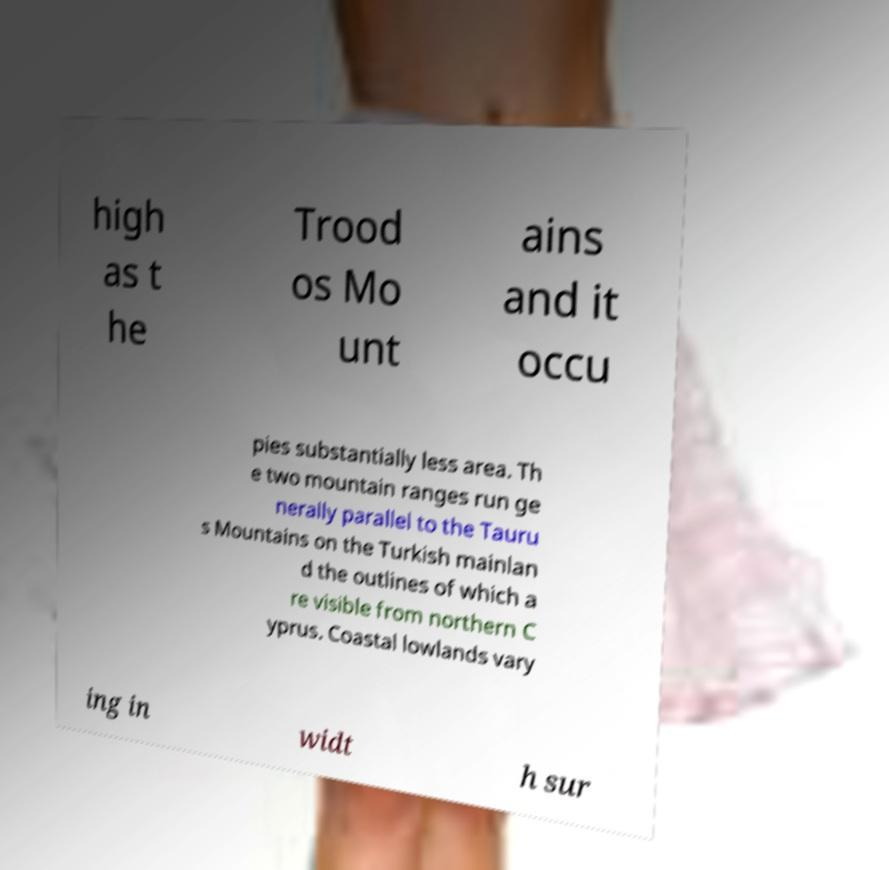There's text embedded in this image that I need extracted. Can you transcribe it verbatim? high as t he Trood os Mo unt ains and it occu pies substantially less area. Th e two mountain ranges run ge nerally parallel to the Tauru s Mountains on the Turkish mainlan d the outlines of which a re visible from northern C yprus. Coastal lowlands vary ing in widt h sur 